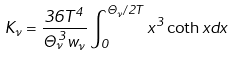<formula> <loc_0><loc_0><loc_500><loc_500>K _ { \nu } = \frac { 3 6 T ^ { 4 } } { \Theta _ { \nu } ^ { 3 } w _ { \nu } } \int _ { 0 } ^ { \Theta _ { \nu } / 2 T } x ^ { 3 } \coth x d x</formula> 